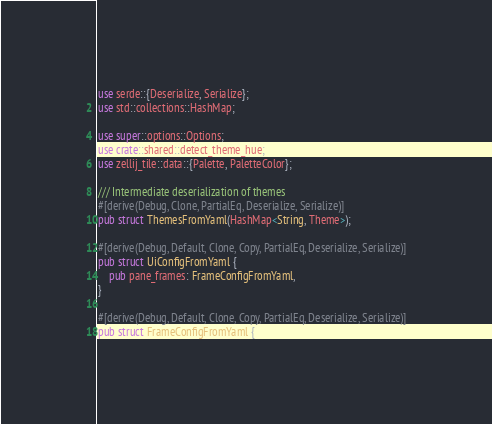<code> <loc_0><loc_0><loc_500><loc_500><_Rust_>use serde::{Deserialize, Serialize};
use std::collections::HashMap;

use super::options::Options;
use crate::shared::detect_theme_hue;
use zellij_tile::data::{Palette, PaletteColor};

/// Intermediate deserialization of themes
#[derive(Debug, Clone, PartialEq, Deserialize, Serialize)]
pub struct ThemesFromYaml(HashMap<String, Theme>);

#[derive(Debug, Default, Clone, Copy, PartialEq, Deserialize, Serialize)]
pub struct UiConfigFromYaml {
    pub pane_frames: FrameConfigFromYaml,
}

#[derive(Debug, Default, Clone, Copy, PartialEq, Deserialize, Serialize)]
pub struct FrameConfigFromYaml {</code> 